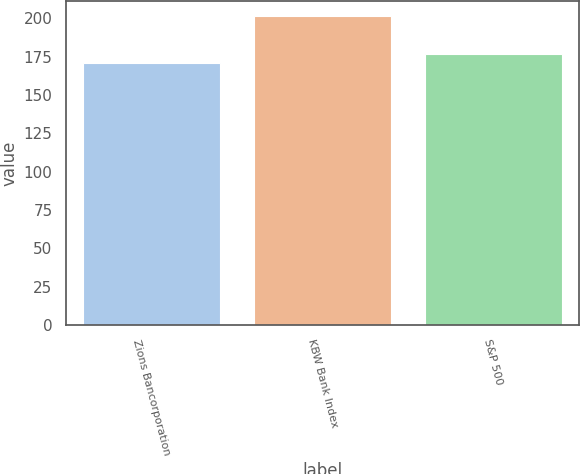Convert chart. <chart><loc_0><loc_0><loc_500><loc_500><bar_chart><fcel>Zions Bancorporation<fcel>KBW Bank Index<fcel>S&P 500<nl><fcel>171<fcel>201.4<fcel>176.9<nl></chart> 